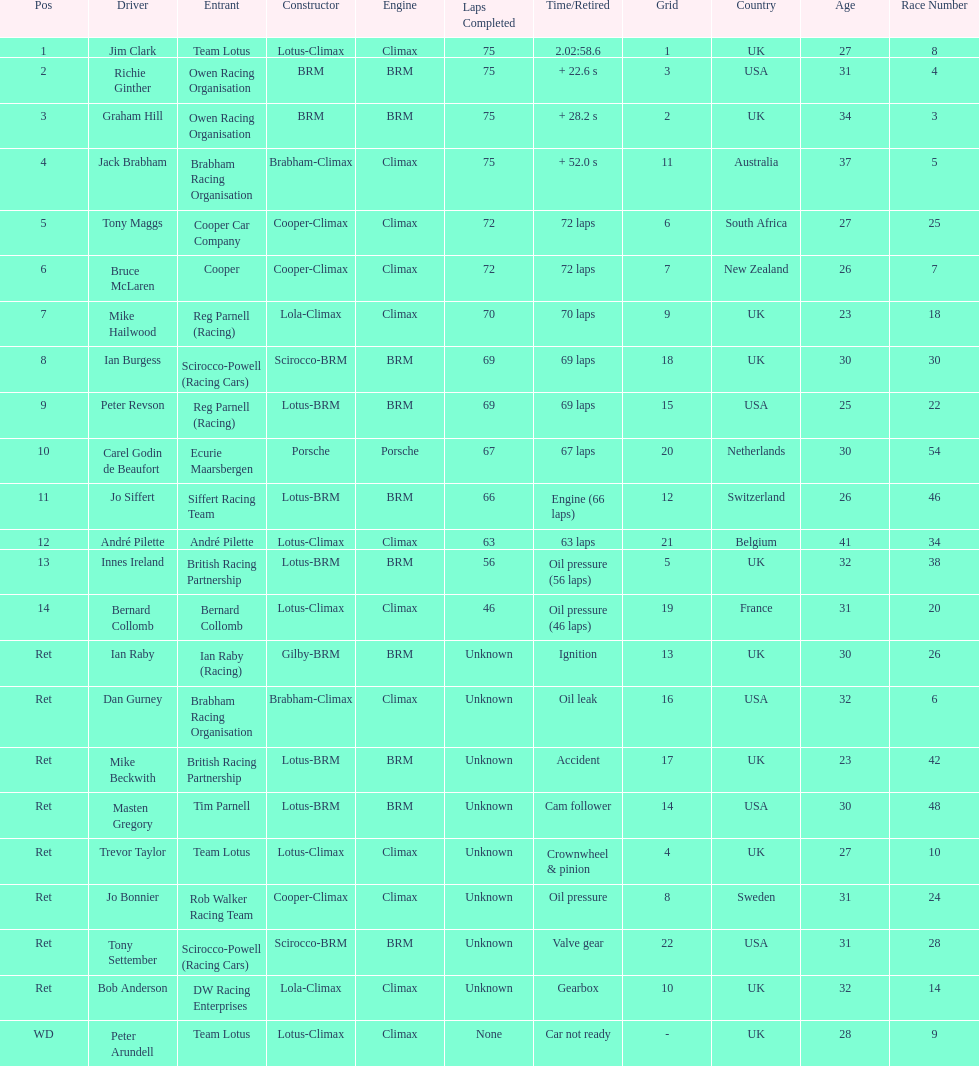Which driver did not have his/her car ready? Peter Arundell. 